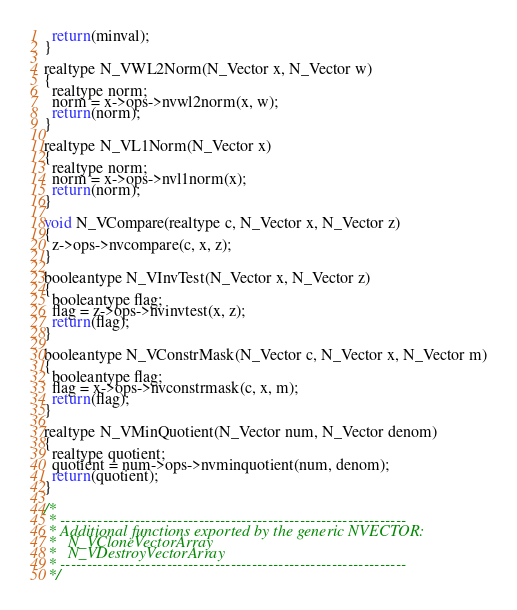Convert code to text. <code><loc_0><loc_0><loc_500><loc_500><_C_>  return(minval);
}

realtype N_VWL2Norm(N_Vector x, N_Vector w)
{
  realtype norm;
  norm = x->ops->nvwl2norm(x, w);
  return(norm);
}

realtype N_VL1Norm(N_Vector x)
{
  realtype norm;
  norm = x->ops->nvl1norm(x);
  return(norm);
}

void N_VCompare(realtype c, N_Vector x, N_Vector z)
{
  z->ops->nvcompare(c, x, z);
}

booleantype N_VInvTest(N_Vector x, N_Vector z)
{
  booleantype flag;
  flag = z->ops->nvinvtest(x, z);
  return(flag);
}

booleantype N_VConstrMask(N_Vector c, N_Vector x, N_Vector m)
{
  booleantype flag;
  flag = x->ops->nvconstrmask(c, x, m);
  return(flag);
}

realtype N_VMinQuotient(N_Vector num, N_Vector denom)
{
  realtype quotient;
  quotient = num->ops->nvminquotient(num, denom);
  return(quotient);
}

/*
 * -----------------------------------------------------------------
 * Additional functions exported by the generic NVECTOR:
 *   N_VCloneVectorArray
 *   N_VDestroyVectorArray
 * -----------------------------------------------------------------
 */
</code> 